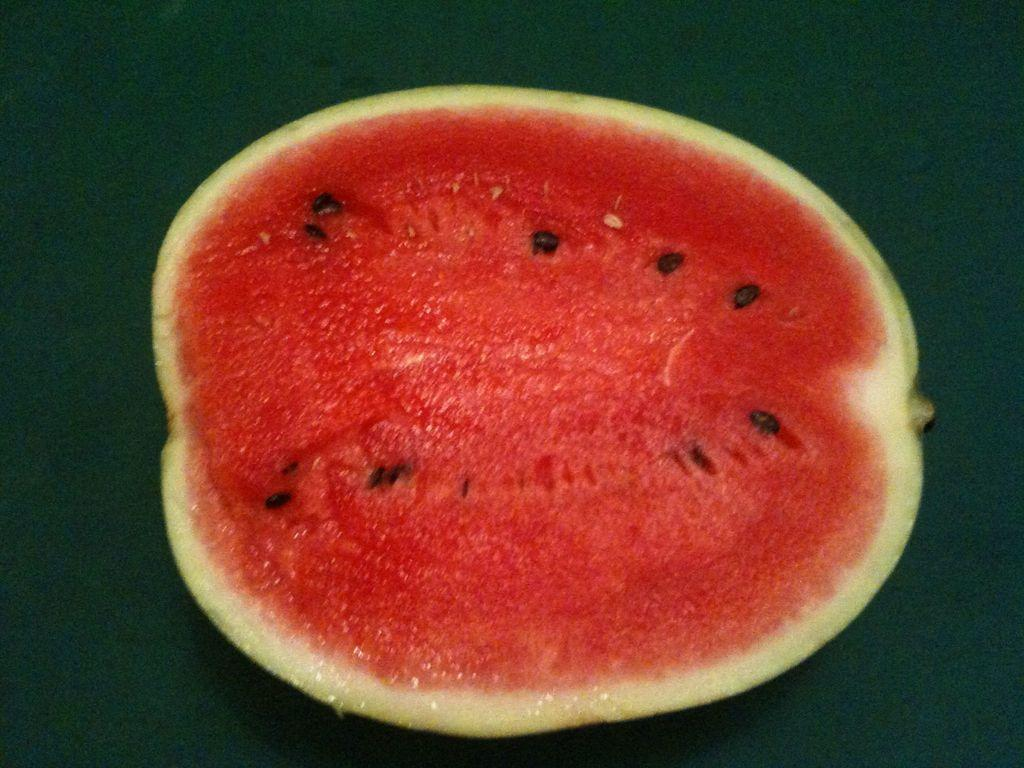What type of fruit is visible in the image? There is a half piece of watermelon in the image. What color is the background of the image? The background of the image is green. What type of alley can be seen in the image? There is no alley present in the image; it features a half piece of watermelon against a green background. What kind of potato is being used by the carpenter in the image? There is no carpenter or potato present in the image; it only shows a half piece of watermelon and a green background. 